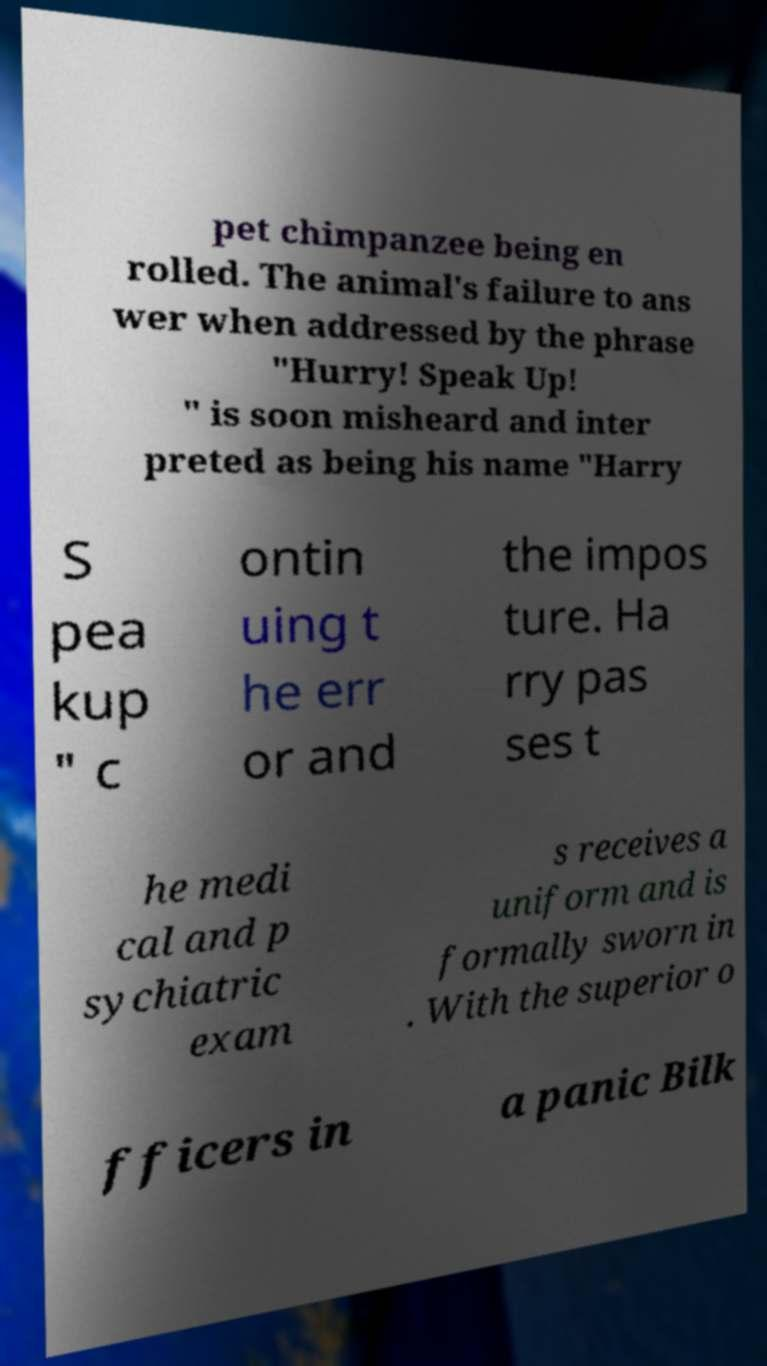For documentation purposes, I need the text within this image transcribed. Could you provide that? pet chimpanzee being en rolled. The animal's failure to ans wer when addressed by the phrase "Hurry! Speak Up! " is soon misheard and inter preted as being his name "Harry S pea kup " c ontin uing t he err or and the impos ture. Ha rry pas ses t he medi cal and p sychiatric exam s receives a uniform and is formally sworn in . With the superior o fficers in a panic Bilk 